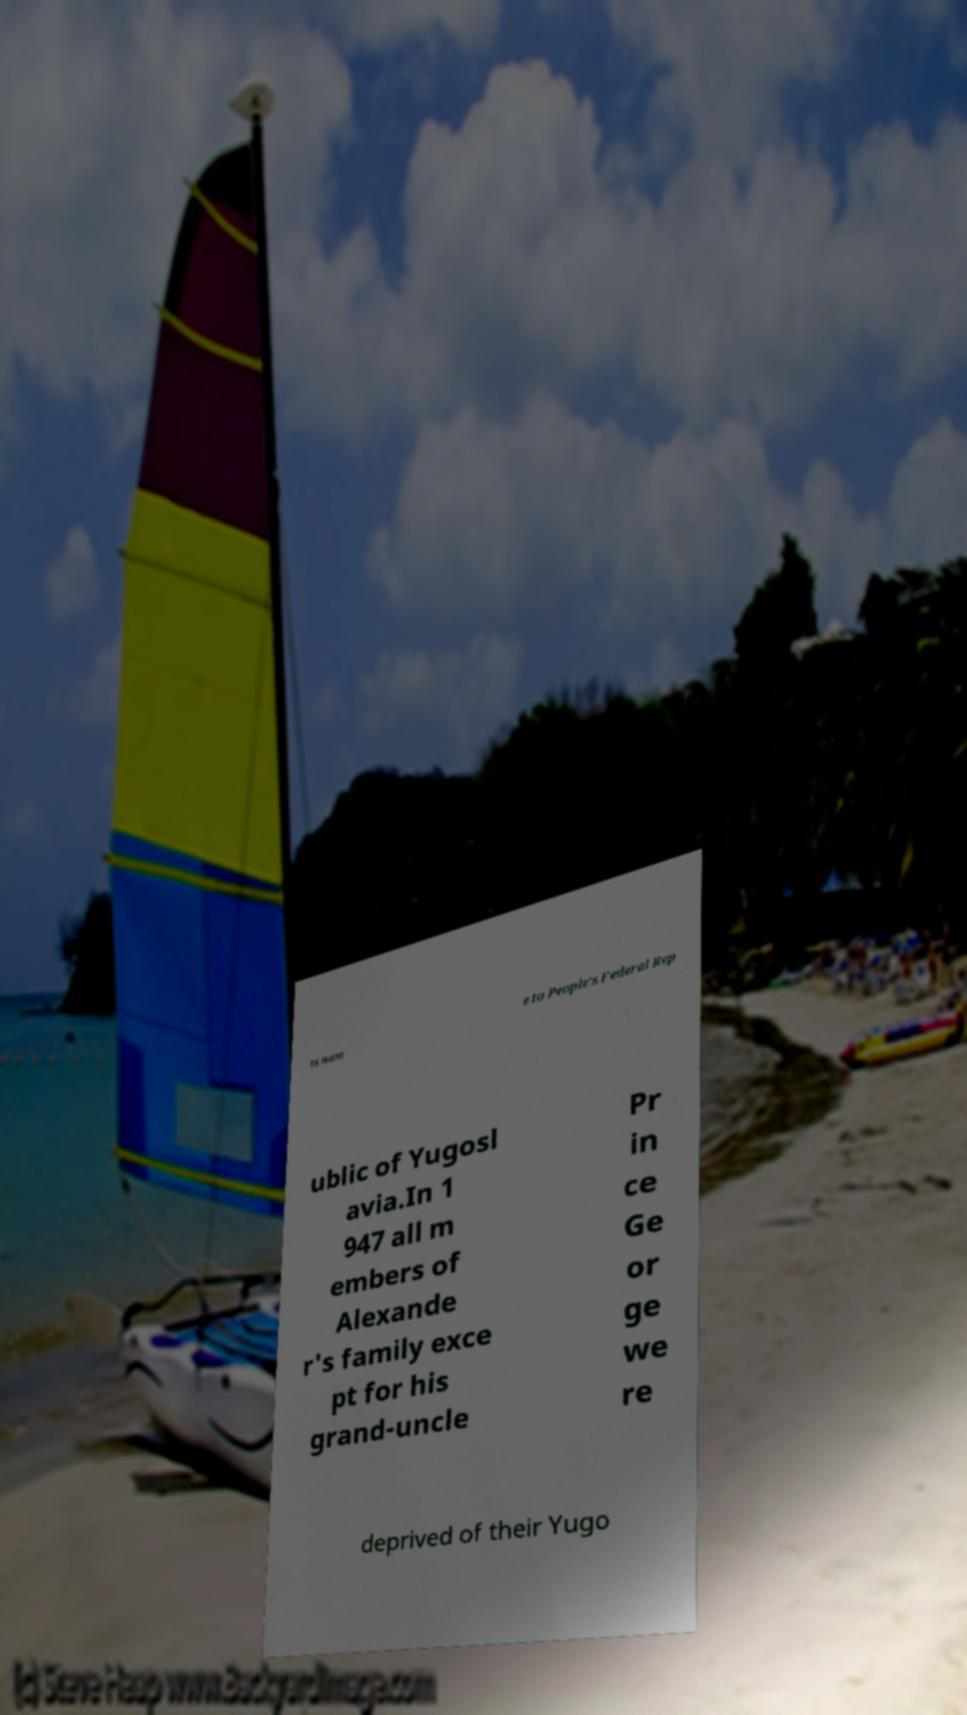What messages or text are displayed in this image? I need them in a readable, typed format. ts nam e to People's Federal Rep ublic of Yugosl avia.In 1 947 all m embers of Alexande r's family exce pt for his grand-uncle Pr in ce Ge or ge we re deprived of their Yugo 